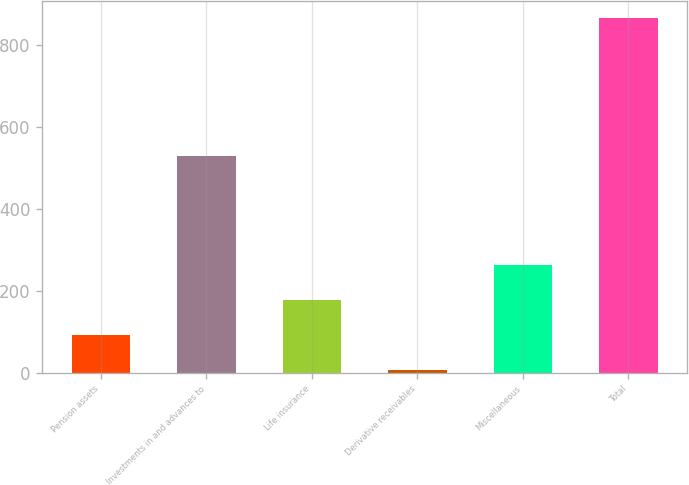<chart> <loc_0><loc_0><loc_500><loc_500><bar_chart><fcel>Pension assets<fcel>Investments in and advances to<fcel>Life insurance<fcel>Derivative receivables<fcel>Miscellaneous<fcel>Total<nl><fcel>92.11<fcel>529<fcel>178.02<fcel>6.2<fcel>263.93<fcel>865.3<nl></chart> 